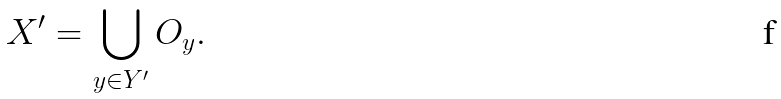<formula> <loc_0><loc_0><loc_500><loc_500>X ^ { \prime } = \bigcup _ { y \in Y ^ { \prime } } O _ { y } .</formula> 